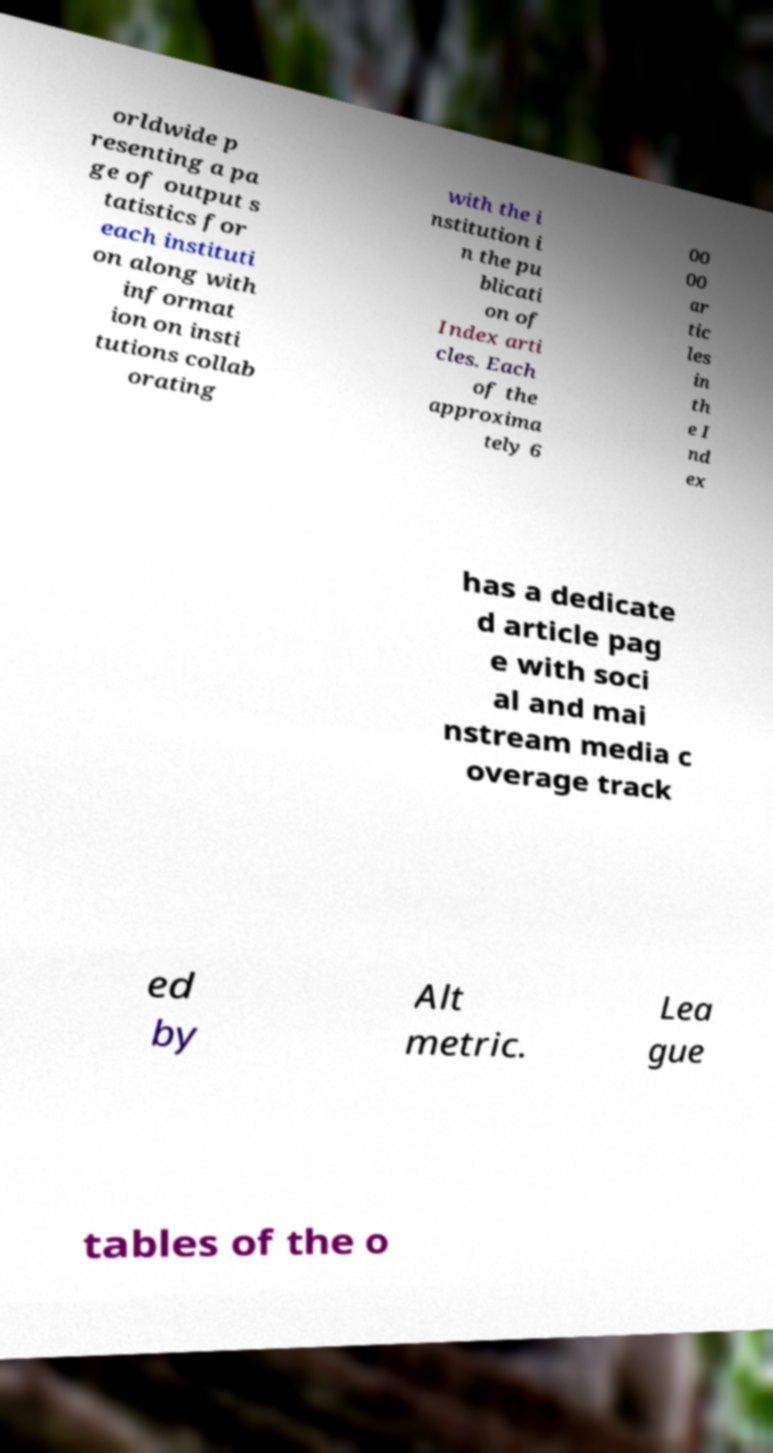There's text embedded in this image that I need extracted. Can you transcribe it verbatim? orldwide p resenting a pa ge of output s tatistics for each instituti on along with informat ion on insti tutions collab orating with the i nstitution i n the pu blicati on of Index arti cles. Each of the approxima tely 6 00 00 ar tic les in th e I nd ex has a dedicate d article pag e with soci al and mai nstream media c overage track ed by Alt metric. Lea gue tables of the o 